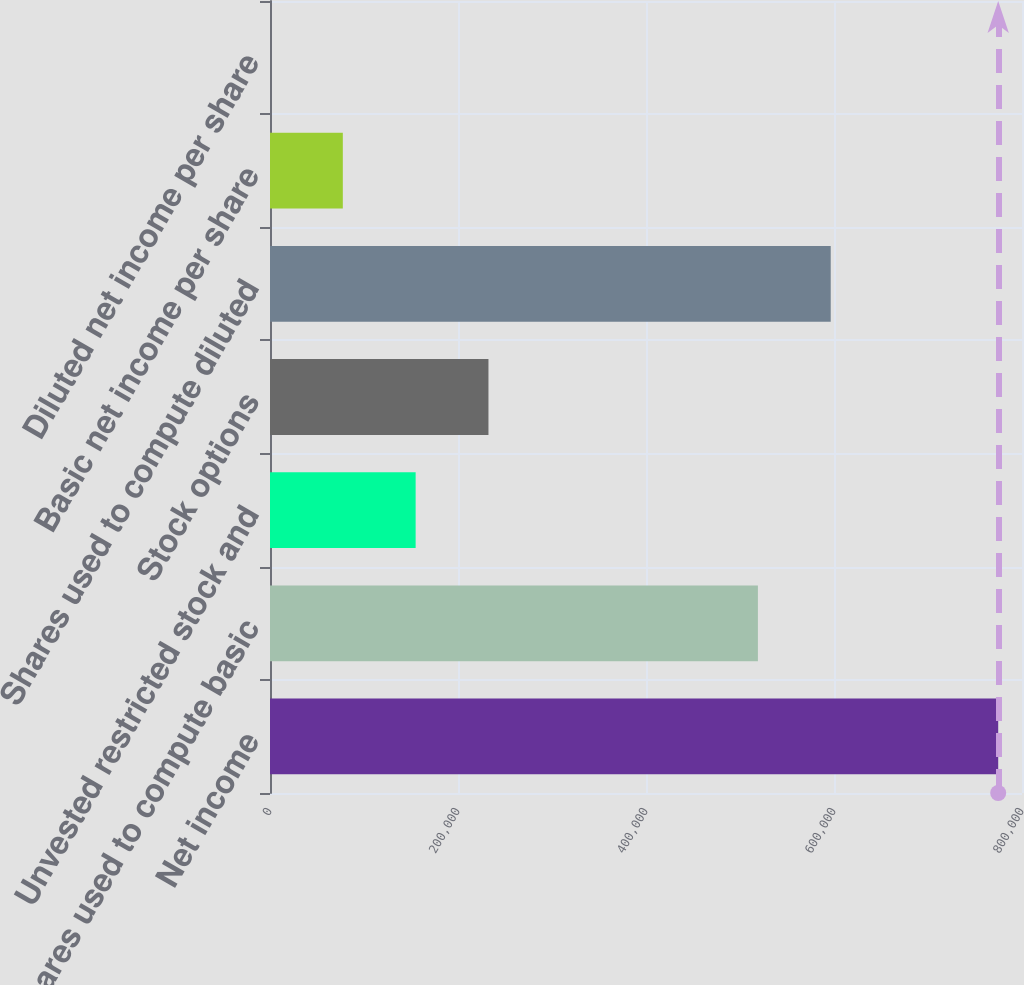Convert chart. <chart><loc_0><loc_0><loc_500><loc_500><bar_chart><fcel>Net income<fcel>Shares used to compute basic<fcel>Unvested restricted stock and<fcel>Stock options<fcel>Shares used to compute diluted<fcel>Basic net income per share<fcel>Diluted net income per share<nl><fcel>774680<fcel>519045<fcel>154937<fcel>232405<fcel>596513<fcel>77469.3<fcel>1.47<nl></chart> 